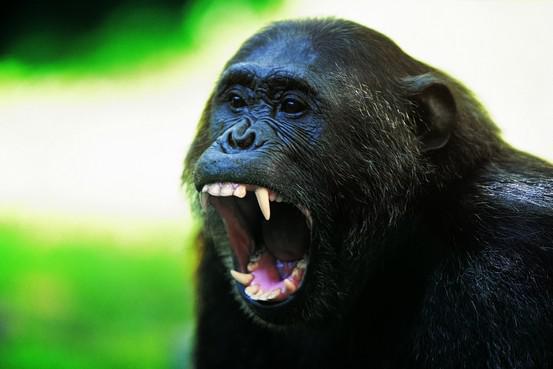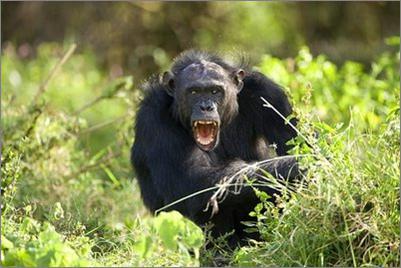The first image is the image on the left, the second image is the image on the right. Considering the images on both sides, is "One image shows a group of chimps outdoors in front of a brown squarish structure, and the other image shows chimps near a tree and manmade structures." valid? Answer yes or no. No. The first image is the image on the left, the second image is the image on the right. Given the left and right images, does the statement "There are more primates in the image on the right." hold true? Answer yes or no. No. 